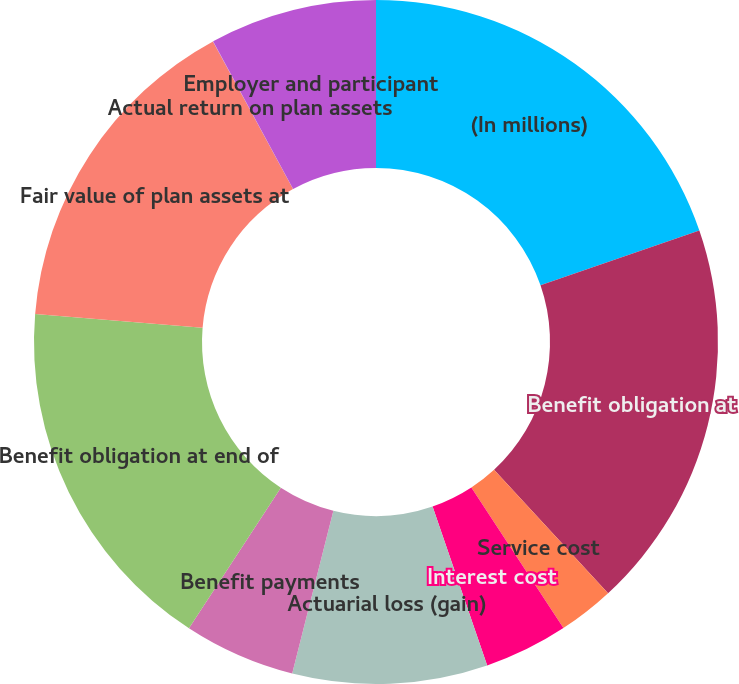Convert chart to OTSL. <chart><loc_0><loc_0><loc_500><loc_500><pie_chart><fcel>(In millions)<fcel>Benefit obligation at<fcel>Service cost<fcel>Interest cost<fcel>Actuarial loss (gain)<fcel>Benefit payments<fcel>Benefit obligation at end of<fcel>Fair value of plan assets at<fcel>Actual return on plan assets<fcel>Employer and participant<nl><fcel>19.72%<fcel>18.41%<fcel>2.64%<fcel>3.96%<fcel>9.21%<fcel>5.27%<fcel>17.1%<fcel>15.78%<fcel>0.01%<fcel>7.9%<nl></chart> 